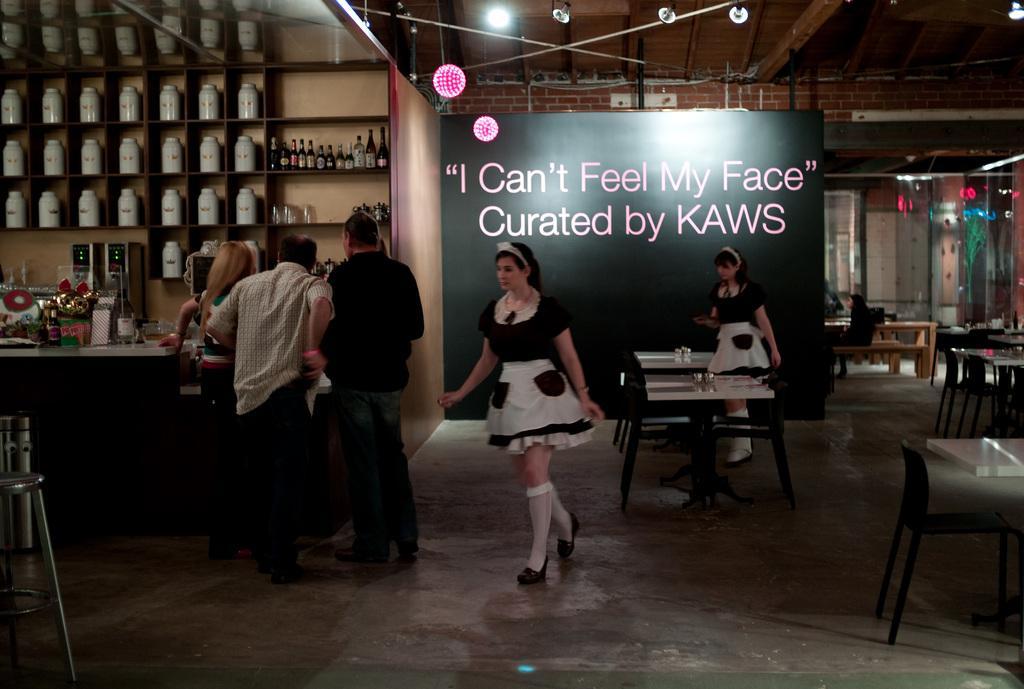Please provide a concise description of this image. Two women wearing white and black dress is walking. There are three persons standing. In the background there is a banner. Also there is a brick wall with lights. In the left side there is a cupboard with many bottles. Also there is a table with bottles and some other items. Near to that there is a dustbin and a stand. There are many tables and chairs in this room. 